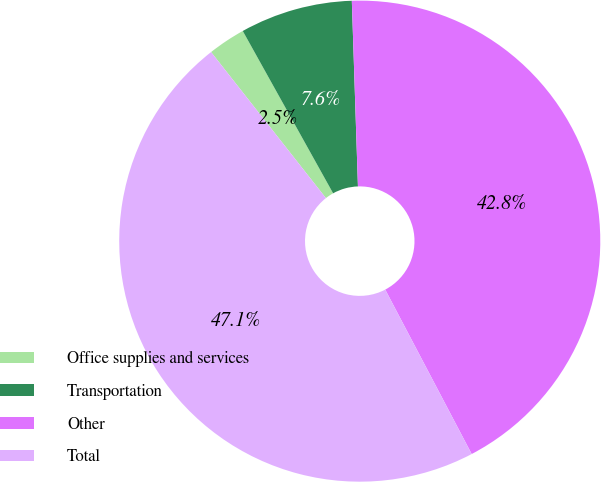Convert chart to OTSL. <chart><loc_0><loc_0><loc_500><loc_500><pie_chart><fcel>Office supplies and services<fcel>Transportation<fcel>Other<fcel>Total<nl><fcel>2.52%<fcel>7.56%<fcel>42.82%<fcel>47.1%<nl></chart> 